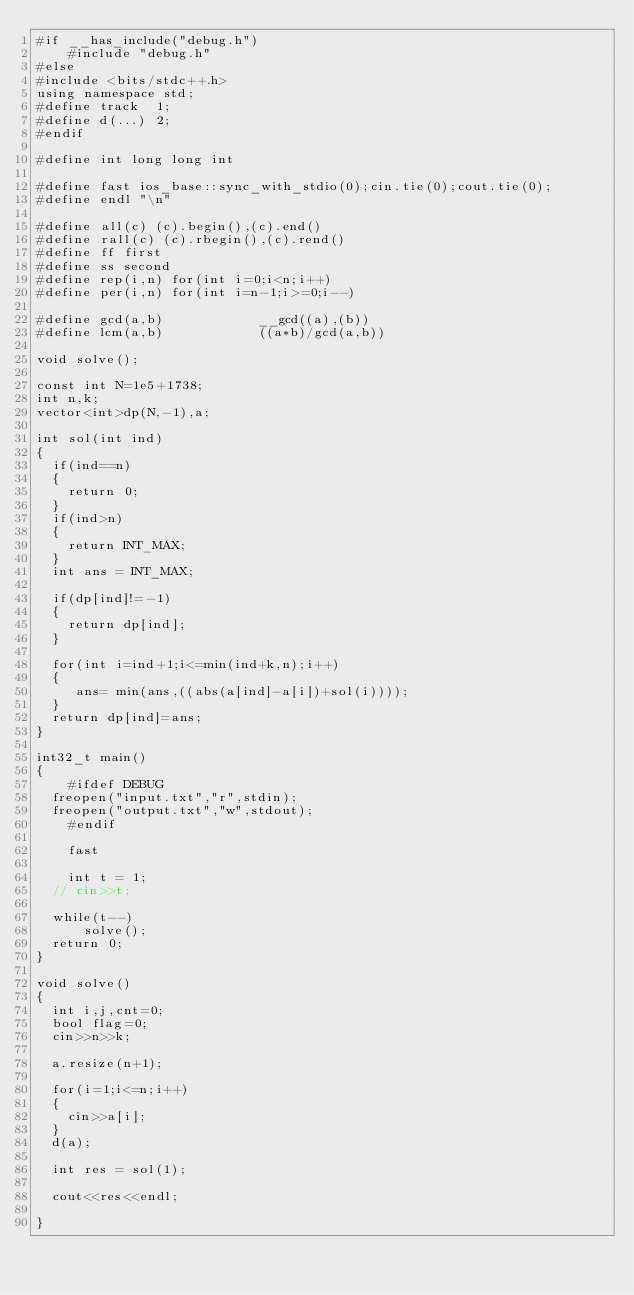Convert code to text. <code><loc_0><loc_0><loc_500><loc_500><_C++_>#if __has_include("debug.h")
    #include "debug.h"
#else  
#include <bits/stdc++.h>
using namespace std;
#define track  1;
#define d(...) 2;
#endif

#define int long long int

#define fast ios_base::sync_with_stdio(0);cin.tie(0);cout.tie(0);
#define endl "\n"      

#define all(c) (c).begin(),(c).end()
#define rall(c) (c).rbegin(),(c).rend()
#define ff first
#define ss second
#define rep(i,n) for(int i=0;i<n;i++)
#define per(i,n) for(int i=n-1;i>=0;i--)

#define gcd(a,b)            __gcd((a),(b))
#define lcm(a,b)            ((a*b)/gcd(a,b))

void solve();

const int N=1e5+1738;
int n,k;
vector<int>dp(N,-1),a;

int sol(int ind)
{
	if(ind==n)
	{
		return 0;
	}
	if(ind>n)
	{
		return INT_MAX;
	}
	int ans = INT_MAX;

	if(dp[ind]!=-1)
	{
		return dp[ind];
	}

	for(int i=ind+1;i<=min(ind+k,n);i++)
	{
		 ans= min(ans,((abs(a[ind]-a[i])+sol(i))));
	}
	return dp[ind]=ans;
}

int32_t main()
{
    #ifdef DEBUG
	freopen("input.txt","r",stdin);
	freopen("output.txt","w",stdout);
    #endif 

    fast
    
    int t = 1;
	// cin>>t;
	
	while(t--)
	    solve();
	return 0;  
}

void solve()
{
	int i,j,cnt=0;
	bool flag=0;
	cin>>n>>k;

	a.resize(n+1);

	for(i=1;i<=n;i++)
	{
		cin>>a[i];
	}
	d(a);

	int res = sol(1);

	cout<<res<<endl;

}</code> 